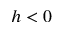Convert formula to latex. <formula><loc_0><loc_0><loc_500><loc_500>h < 0</formula> 